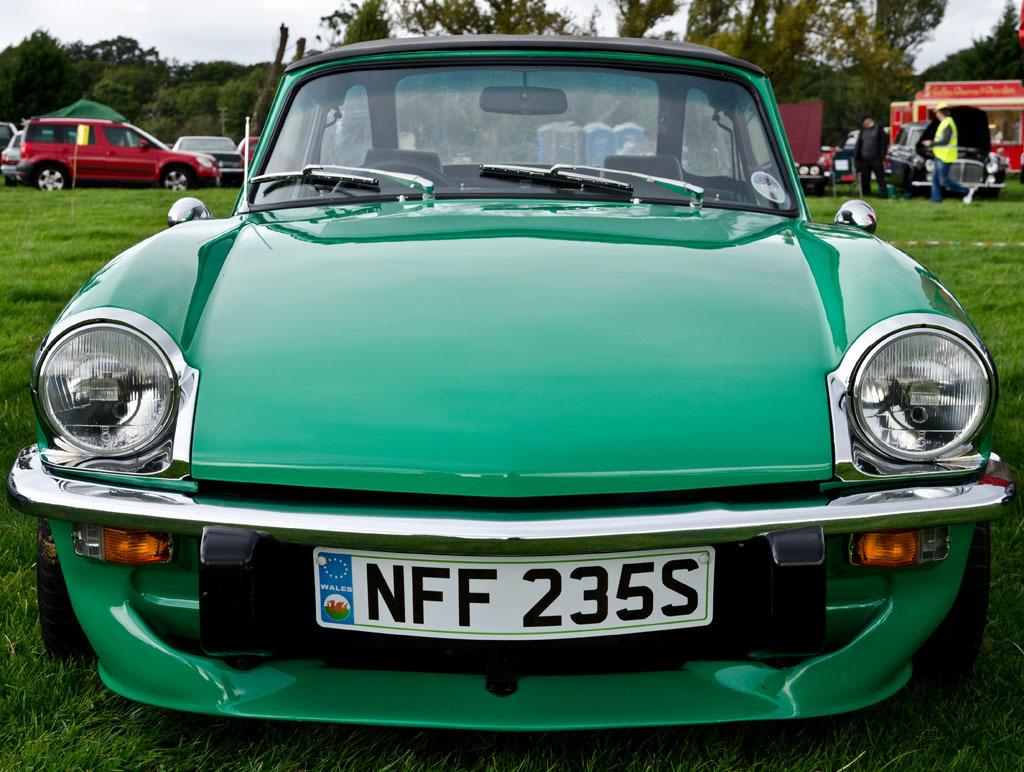What is the main subject of the image? There is a car on the grass in the image. What else can be seen in the background of the image? There are vehicles, people, trees, and the sky visible in the background of the image. How many vehicles are present in the image? There is one car visible in the image, and there are additional vehicles in the background. Can you see any fairies writing in a notebook on a branch in the image? There are no fairies, notebooks, or branches present in the image. 